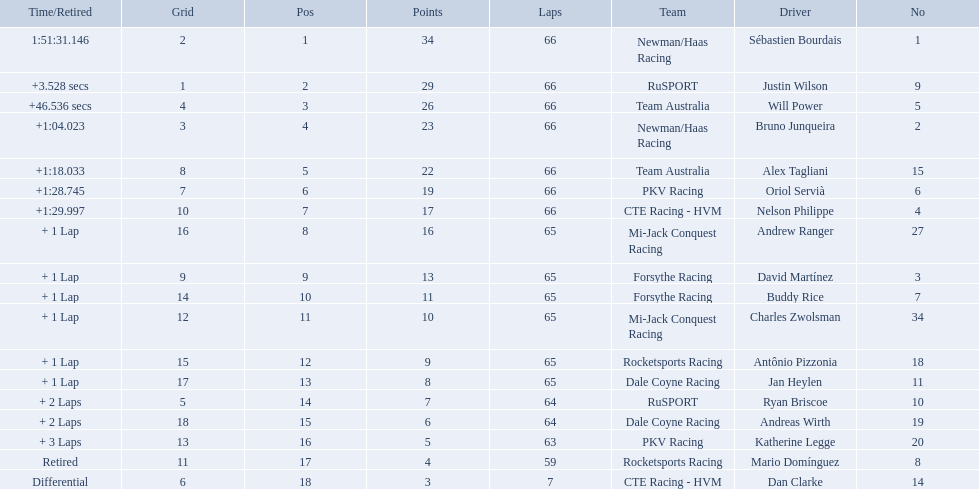Which teams participated in the 2006 gran premio telmex? Newman/Haas Racing, RuSPORT, Team Australia, Newman/Haas Racing, Team Australia, PKV Racing, CTE Racing - HVM, Mi-Jack Conquest Racing, Forsythe Racing, Forsythe Racing, Mi-Jack Conquest Racing, Rocketsports Racing, Dale Coyne Racing, RuSPORT, Dale Coyne Racing, PKV Racing, Rocketsports Racing, CTE Racing - HVM. Who were the drivers of these teams? Sébastien Bourdais, Justin Wilson, Will Power, Bruno Junqueira, Alex Tagliani, Oriol Servià, Nelson Philippe, Andrew Ranger, David Martínez, Buddy Rice, Charles Zwolsman, Antônio Pizzonia, Jan Heylen, Ryan Briscoe, Andreas Wirth, Katherine Legge, Mario Domínguez, Dan Clarke. Can you give me this table as a dict? {'header': ['Time/Retired', 'Grid', 'Pos', 'Points', 'Laps', 'Team', 'Driver', 'No'], 'rows': [['1:51:31.146', '2', '1', '34', '66', 'Newman/Haas Racing', 'Sébastien Bourdais', '1'], ['+3.528 secs', '1', '2', '29', '66', 'RuSPORT', 'Justin Wilson', '9'], ['+46.536 secs', '4', '3', '26', '66', 'Team Australia', 'Will Power', '5'], ['+1:04.023', '3', '4', '23', '66', 'Newman/Haas Racing', 'Bruno Junqueira', '2'], ['+1:18.033', '8', '5', '22', '66', 'Team Australia', 'Alex Tagliani', '15'], ['+1:28.745', '7', '6', '19', '66', 'PKV Racing', 'Oriol Servià', '6'], ['+1:29.997', '10', '7', '17', '66', 'CTE Racing - HVM', 'Nelson Philippe', '4'], ['+ 1 Lap', '16', '8', '16', '65', 'Mi-Jack Conquest Racing', 'Andrew Ranger', '27'], ['+ 1 Lap', '9', '9', '13', '65', 'Forsythe Racing', 'David Martínez', '3'], ['+ 1 Lap', '14', '10', '11', '65', 'Forsythe Racing', 'Buddy Rice', '7'], ['+ 1 Lap', '12', '11', '10', '65', 'Mi-Jack Conquest Racing', 'Charles Zwolsman', '34'], ['+ 1 Lap', '15', '12', '9', '65', 'Rocketsports Racing', 'Antônio Pizzonia', '18'], ['+ 1 Lap', '17', '13', '8', '65', 'Dale Coyne Racing', 'Jan Heylen', '11'], ['+ 2 Laps', '5', '14', '7', '64', 'RuSPORT', 'Ryan Briscoe', '10'], ['+ 2 Laps', '18', '15', '6', '64', 'Dale Coyne Racing', 'Andreas Wirth', '19'], ['+ 3 Laps', '13', '16', '5', '63', 'PKV Racing', 'Katherine Legge', '20'], ['Retired', '11', '17', '4', '59', 'Rocketsports Racing', 'Mario Domínguez', '8'], ['Differential', '6', '18', '3', '7', 'CTE Racing - HVM', 'Dan Clarke', '14']]} Which driver finished last? Dan Clarke. Who are the drivers? Sébastien Bourdais, Justin Wilson, Will Power, Bruno Junqueira, Alex Tagliani, Oriol Servià, Nelson Philippe, Andrew Ranger, David Martínez, Buddy Rice, Charles Zwolsman, Antônio Pizzonia, Jan Heylen, Ryan Briscoe, Andreas Wirth, Katherine Legge, Mario Domínguez, Dan Clarke. I'm looking to parse the entire table for insights. Could you assist me with that? {'header': ['Time/Retired', 'Grid', 'Pos', 'Points', 'Laps', 'Team', 'Driver', 'No'], 'rows': [['1:51:31.146', '2', '1', '34', '66', 'Newman/Haas Racing', 'Sébastien Bourdais', '1'], ['+3.528 secs', '1', '2', '29', '66', 'RuSPORT', 'Justin Wilson', '9'], ['+46.536 secs', '4', '3', '26', '66', 'Team Australia', 'Will Power', '5'], ['+1:04.023', '3', '4', '23', '66', 'Newman/Haas Racing', 'Bruno Junqueira', '2'], ['+1:18.033', '8', '5', '22', '66', 'Team Australia', 'Alex Tagliani', '15'], ['+1:28.745', '7', '6', '19', '66', 'PKV Racing', 'Oriol Servià', '6'], ['+1:29.997', '10', '7', '17', '66', 'CTE Racing - HVM', 'Nelson Philippe', '4'], ['+ 1 Lap', '16', '8', '16', '65', 'Mi-Jack Conquest Racing', 'Andrew Ranger', '27'], ['+ 1 Lap', '9', '9', '13', '65', 'Forsythe Racing', 'David Martínez', '3'], ['+ 1 Lap', '14', '10', '11', '65', 'Forsythe Racing', 'Buddy Rice', '7'], ['+ 1 Lap', '12', '11', '10', '65', 'Mi-Jack Conquest Racing', 'Charles Zwolsman', '34'], ['+ 1 Lap', '15', '12', '9', '65', 'Rocketsports Racing', 'Antônio Pizzonia', '18'], ['+ 1 Lap', '17', '13', '8', '65', 'Dale Coyne Racing', 'Jan Heylen', '11'], ['+ 2 Laps', '5', '14', '7', '64', 'RuSPORT', 'Ryan Briscoe', '10'], ['+ 2 Laps', '18', '15', '6', '64', 'Dale Coyne Racing', 'Andreas Wirth', '19'], ['+ 3 Laps', '13', '16', '5', '63', 'PKV Racing', 'Katherine Legge', '20'], ['Retired', '11', '17', '4', '59', 'Rocketsports Racing', 'Mario Domínguez', '8'], ['Differential', '6', '18', '3', '7', 'CTE Racing - HVM', 'Dan Clarke', '14']]} What are their numbers? 1, 9, 5, 2, 15, 6, 4, 27, 3, 7, 34, 18, 11, 10, 19, 20, 8, 14. What are their positions? 1, 2, 3, 4, 5, 6, 7, 8, 9, 10, 11, 12, 13, 14, 15, 16, 17, 18. Which driver has the same number and position? Sébastien Bourdais. Who are all the drivers? Sébastien Bourdais, Justin Wilson, Will Power, Bruno Junqueira, Alex Tagliani, Oriol Servià, Nelson Philippe, Andrew Ranger, David Martínez, Buddy Rice, Charles Zwolsman, Antônio Pizzonia, Jan Heylen, Ryan Briscoe, Andreas Wirth, Katherine Legge, Mario Domínguez, Dan Clarke. What position did they reach? 1, 2, 3, 4, 5, 6, 7, 8, 9, 10, 11, 12, 13, 14, 15, 16, 17, 18. What is the number for each driver? 1, 9, 5, 2, 15, 6, 4, 27, 3, 7, 34, 18, 11, 10, 19, 20, 8, 14. And which player's number and position match? Sébastien Bourdais. 